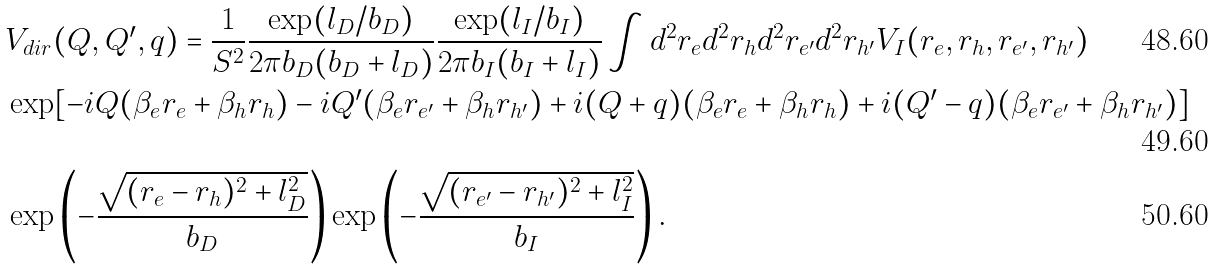Convert formula to latex. <formula><loc_0><loc_0><loc_500><loc_500>& V _ { d i r } ( Q , Q ^ { \prime } , q ) = \frac { 1 } { S ^ { 2 } } \frac { \exp ( l _ { D } / b _ { D } ) } { 2 \pi b _ { D } ( b _ { D } + l _ { D } ) } \frac { \exp ( l _ { I } / b _ { I } ) } { 2 \pi b _ { I } ( b _ { I } + l _ { I } ) } \int d ^ { 2 } r _ { e } d ^ { 2 } r _ { h } d ^ { 2 } r _ { e ^ { \prime } } d ^ { 2 } r _ { h ^ { \prime } } V _ { I } ( r _ { e } , r _ { h } , r _ { e ^ { \prime } } , r _ { h ^ { \prime } } ) \\ & \exp [ - i Q ( \beta _ { e } r _ { e } + \beta _ { h } r _ { h } ) - i Q ^ { \prime } ( \beta _ { e } r _ { e ^ { \prime } } + \beta _ { h } r _ { h ^ { \prime } } ) + i ( Q + q ) ( \beta _ { e } r _ { e } + \beta _ { h } r _ { h } ) + i ( Q ^ { \prime } - q ) ( \beta _ { e } r _ { e ^ { \prime } } + \beta _ { h } r _ { h ^ { \prime } } ) ] \\ & \exp \left ( - \frac { \sqrt { ( r _ { e } - r _ { h } ) ^ { 2 } + l _ { D } ^ { 2 } } } { b _ { D } } \right ) \exp \left ( - \frac { \sqrt { ( r _ { e ^ { \prime } } - r _ { h ^ { \prime } } ) ^ { 2 } + l _ { I } ^ { 2 } } } { b _ { I } } \right ) .</formula> 